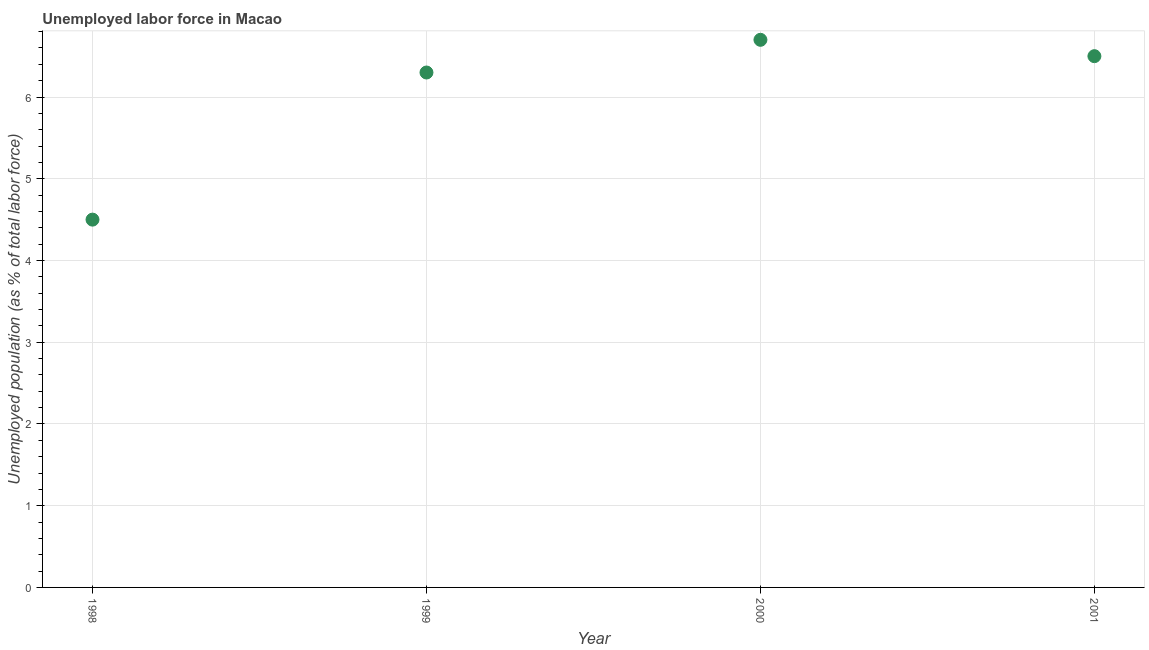What is the total unemployed population in 1998?
Offer a terse response. 4.5. Across all years, what is the maximum total unemployed population?
Your answer should be compact. 6.7. Across all years, what is the minimum total unemployed population?
Make the answer very short. 4.5. In which year was the total unemployed population maximum?
Offer a terse response. 2000. In which year was the total unemployed population minimum?
Your answer should be very brief. 1998. What is the sum of the total unemployed population?
Your response must be concise. 24. What is the difference between the total unemployed population in 1999 and 2001?
Offer a very short reply. -0.2. What is the average total unemployed population per year?
Keep it short and to the point. 6. What is the median total unemployed population?
Provide a short and direct response. 6.4. In how many years, is the total unemployed population greater than 1.6 %?
Keep it short and to the point. 4. Do a majority of the years between 1999 and 1998 (inclusive) have total unemployed population greater than 4.4 %?
Your answer should be compact. No. What is the ratio of the total unemployed population in 1998 to that in 2001?
Your answer should be very brief. 0.69. Is the total unemployed population in 1998 less than that in 2000?
Make the answer very short. Yes. Is the difference between the total unemployed population in 2000 and 2001 greater than the difference between any two years?
Make the answer very short. No. What is the difference between the highest and the second highest total unemployed population?
Your answer should be compact. 0.2. Is the sum of the total unemployed population in 1999 and 2000 greater than the maximum total unemployed population across all years?
Your answer should be compact. Yes. What is the difference between the highest and the lowest total unemployed population?
Provide a succinct answer. 2.2. In how many years, is the total unemployed population greater than the average total unemployed population taken over all years?
Provide a succinct answer. 3. Does the total unemployed population monotonically increase over the years?
Keep it short and to the point. No. How many dotlines are there?
Your response must be concise. 1. What is the difference between two consecutive major ticks on the Y-axis?
Offer a terse response. 1. Are the values on the major ticks of Y-axis written in scientific E-notation?
Offer a terse response. No. What is the title of the graph?
Keep it short and to the point. Unemployed labor force in Macao. What is the label or title of the Y-axis?
Give a very brief answer. Unemployed population (as % of total labor force). What is the Unemployed population (as % of total labor force) in 1998?
Offer a terse response. 4.5. What is the Unemployed population (as % of total labor force) in 1999?
Offer a very short reply. 6.3. What is the Unemployed population (as % of total labor force) in 2000?
Make the answer very short. 6.7. What is the difference between the Unemployed population (as % of total labor force) in 1998 and 1999?
Keep it short and to the point. -1.8. What is the difference between the Unemployed population (as % of total labor force) in 1998 and 2001?
Provide a short and direct response. -2. What is the difference between the Unemployed population (as % of total labor force) in 2000 and 2001?
Ensure brevity in your answer.  0.2. What is the ratio of the Unemployed population (as % of total labor force) in 1998 to that in 1999?
Give a very brief answer. 0.71. What is the ratio of the Unemployed population (as % of total labor force) in 1998 to that in 2000?
Make the answer very short. 0.67. What is the ratio of the Unemployed population (as % of total labor force) in 1998 to that in 2001?
Make the answer very short. 0.69. What is the ratio of the Unemployed population (as % of total labor force) in 2000 to that in 2001?
Give a very brief answer. 1.03. 